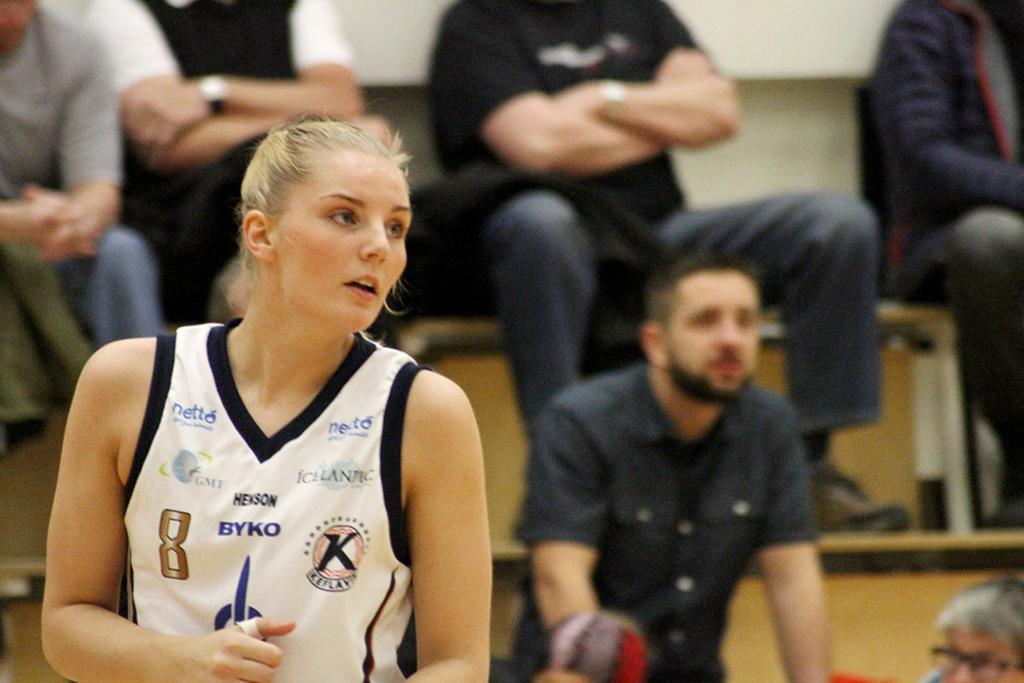Please provide a concise description of this image. In this picture we can observe a woman wearing white color T shirt. In the background there are some people sitting and standing. We can observe a man standing. The background is partially blurred. 